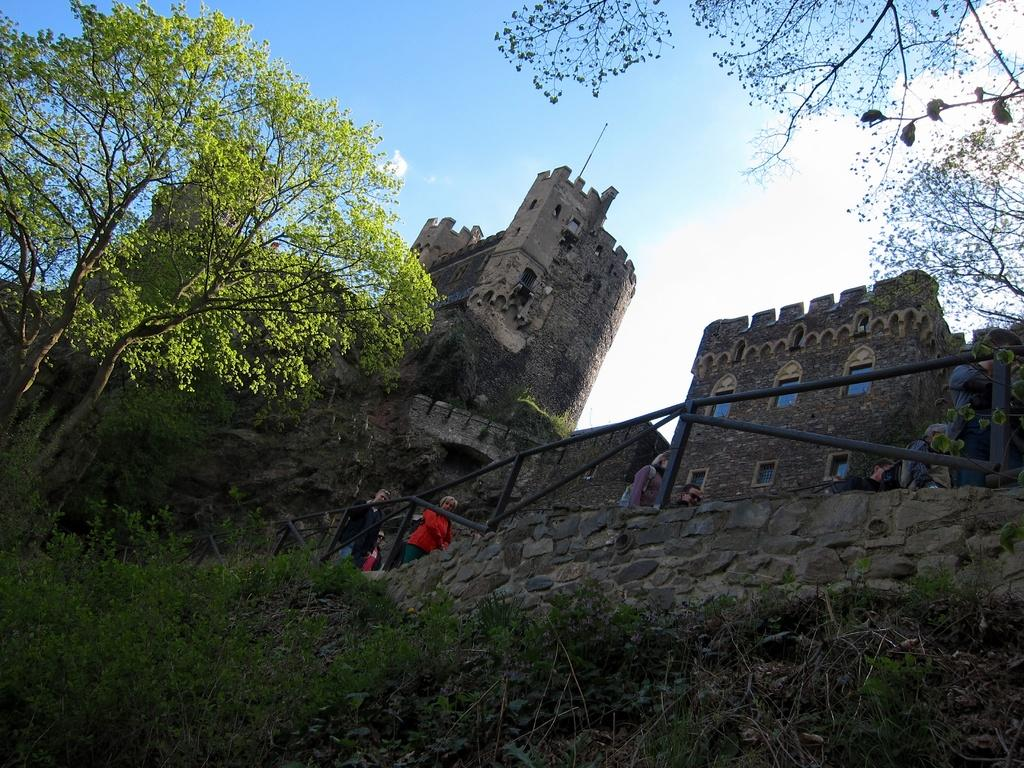How many people are in the image? There is a group of people in the image. What are the people doing in the image? The people are standing at a fence. What type of vegetation can be seen in the image? There are trees in the image. What type of structure is present in the image? There is a wall in the image. What type of buildings can be seen in the image? There are buildings with windows in the image. What is visible in the background of the image? The sky with clouds is visible in the background of the image. What type of boat can be seen in the throat of the person in the image? There is no boat present in the image, nor is there any reference to a person's throat. 